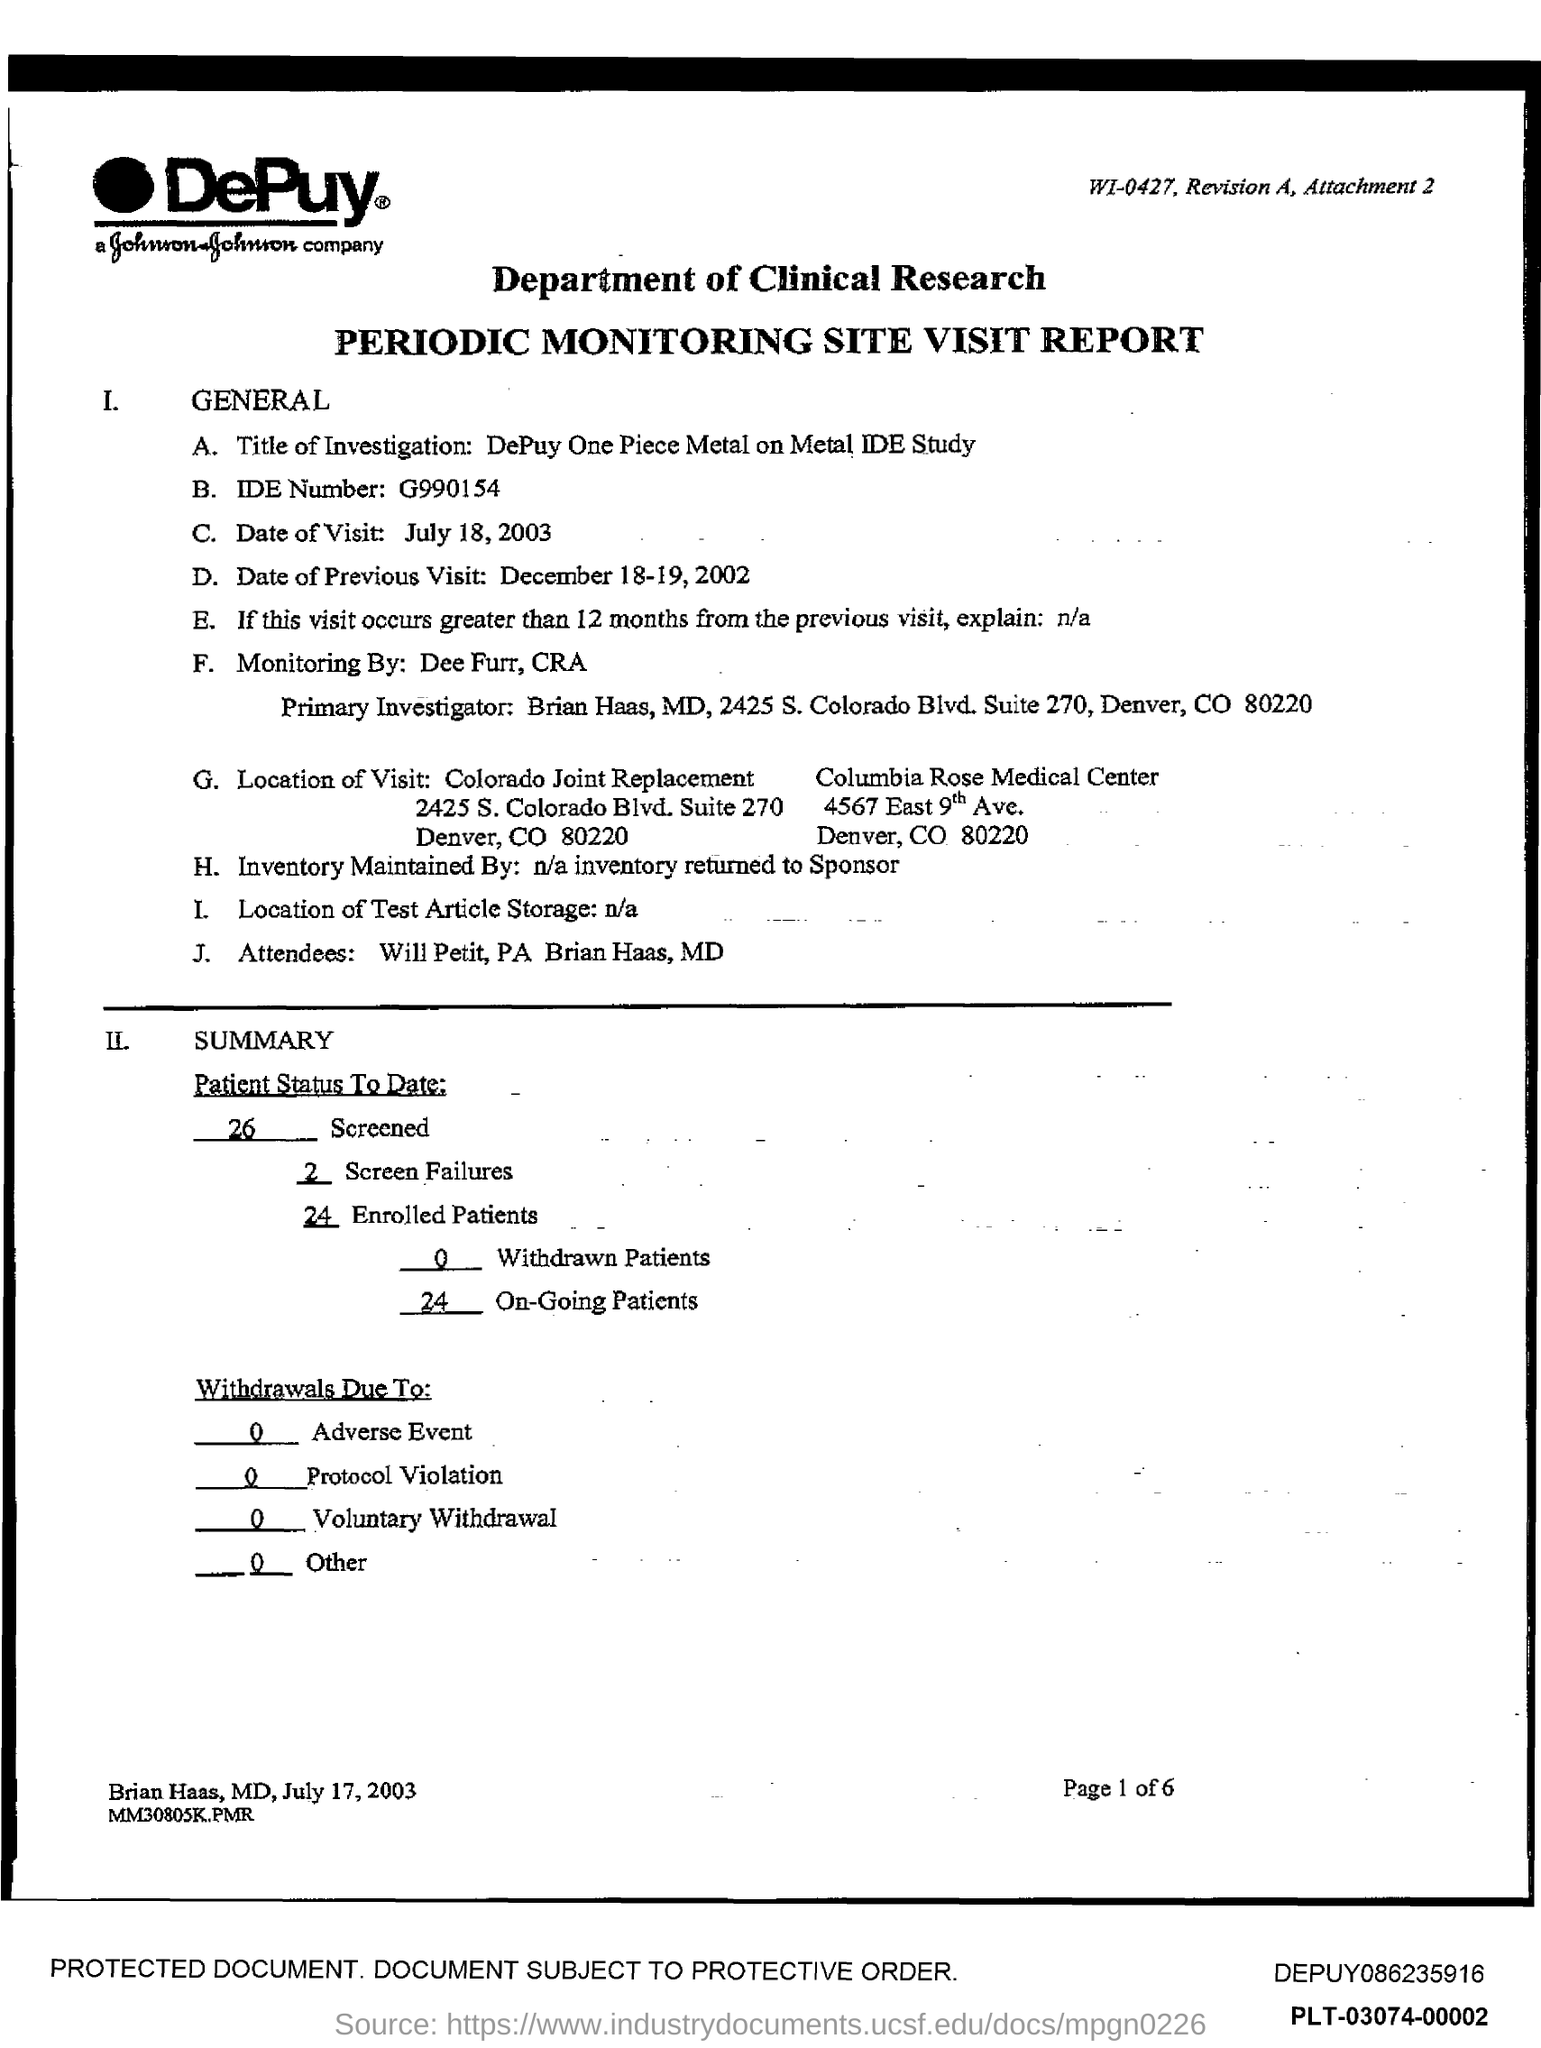What is the ide number ?
Your answer should be very brief. G990154. What is the date of visit ?
Give a very brief answer. July 18, 2003. What is the date of previous visit ?
Your answer should be very brief. December 18-19,2002. In which state is colorado joint replacement?
Your answer should be compact. CO. What is the zipcode of colorado joint replacement?
Ensure brevity in your answer.  80220. What is the zipcode of columbia rose medical center ?
Your answer should be compact. 80220. What is the name of primary investigator ?
Your answer should be very brief. Brian Haas. 